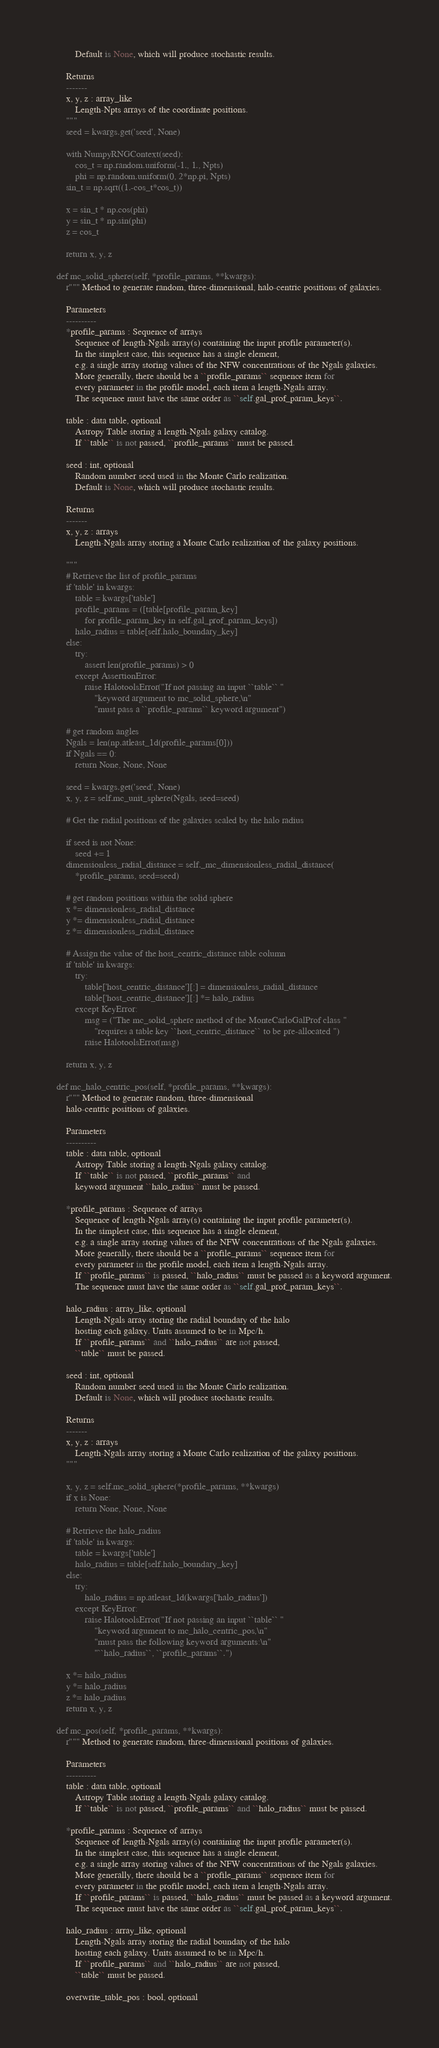Convert code to text. <code><loc_0><loc_0><loc_500><loc_500><_Python_>            Default is None, which will produce stochastic results.

        Returns
        -------
        x, y, z : array_like
            Length-Npts arrays of the coordinate positions.
        """
        seed = kwargs.get('seed', None)

        with NumpyRNGContext(seed):
            cos_t = np.random.uniform(-1., 1., Npts)
            phi = np.random.uniform(0, 2*np.pi, Npts)
        sin_t = np.sqrt((1.-cos_t*cos_t))

        x = sin_t * np.cos(phi)
        y = sin_t * np.sin(phi)
        z = cos_t

        return x, y, z

    def mc_solid_sphere(self, *profile_params, **kwargs):
        r""" Method to generate random, three-dimensional, halo-centric positions of galaxies.

        Parameters
        ----------
        *profile_params : Sequence of arrays
            Sequence of length-Ngals array(s) containing the input profile parameter(s).
            In the simplest case, this sequence has a single element,
            e.g. a single array storing values of the NFW concentrations of the Ngals galaxies.
            More generally, there should be a ``profile_params`` sequence item for
            every parameter in the profile model, each item a length-Ngals array.
            The sequence must have the same order as ``self.gal_prof_param_keys``.

        table : data table, optional
            Astropy Table storing a length-Ngals galaxy catalog.
            If ``table`` is not passed, ``profile_params`` must be passed.

        seed : int, optional
            Random number seed used in the Monte Carlo realization.
            Default is None, which will produce stochastic results.

        Returns
        -------
        x, y, z : arrays
            Length-Ngals array storing a Monte Carlo realization of the galaxy positions.

        """
        # Retrieve the list of profile_params
        if 'table' in kwargs:
            table = kwargs['table']
            profile_params = ([table[profile_param_key]
                for profile_param_key in self.gal_prof_param_keys])
            halo_radius = table[self.halo_boundary_key]
        else:
            try:
                assert len(profile_params) > 0
            except AssertionError:
                raise HalotoolsError("If not passing an input ``table`` "
                    "keyword argument to mc_solid_sphere,\n"
                    "must pass a ``profile_params`` keyword argument")

        # get random angles
        Ngals = len(np.atleast_1d(profile_params[0]))
        if Ngals == 0:
            return None, None, None

        seed = kwargs.get('seed', None)
        x, y, z = self.mc_unit_sphere(Ngals, seed=seed)

        # Get the radial positions of the galaxies scaled by the halo radius

        if seed is not None:
            seed += 1
        dimensionless_radial_distance = self._mc_dimensionless_radial_distance(
            *profile_params, seed=seed)

        # get random positions within the solid sphere
        x *= dimensionless_radial_distance
        y *= dimensionless_radial_distance
        z *= dimensionless_radial_distance

        # Assign the value of the host_centric_distance table column
        if 'table' in kwargs:
            try:
                table['host_centric_distance'][:] = dimensionless_radial_distance
                table['host_centric_distance'][:] *= halo_radius
            except KeyError:
                msg = ("The mc_solid_sphere method of the MonteCarloGalProf class "
                    "requires a table key ``host_centric_distance`` to be pre-allocated ")
                raise HalotoolsError(msg)

        return x, y, z

    def mc_halo_centric_pos(self, *profile_params, **kwargs):
        r""" Method to generate random, three-dimensional
        halo-centric positions of galaxies.

        Parameters
        ----------
        table : data table, optional
            Astropy Table storing a length-Ngals galaxy catalog.
            If ``table`` is not passed, ``profile_params`` and
            keyword argument ``halo_radius`` must be passed.

        *profile_params : Sequence of arrays
            Sequence of length-Ngals array(s) containing the input profile parameter(s).
            In the simplest case, this sequence has a single element,
            e.g. a single array storing values of the NFW concentrations of the Ngals galaxies.
            More generally, there should be a ``profile_params`` sequence item for
            every parameter in the profile model, each item a length-Ngals array.
            If ``profile_params`` is passed, ``halo_radius`` must be passed as a keyword argument.
            The sequence must have the same order as ``self.gal_prof_param_keys``.

        halo_radius : array_like, optional
            Length-Ngals array storing the radial boundary of the halo
            hosting each galaxy. Units assumed to be in Mpc/h.
            If ``profile_params`` and ``halo_radius`` are not passed,
            ``table`` must be passed.

        seed : int, optional
            Random number seed used in the Monte Carlo realization.
            Default is None, which will produce stochastic results.

        Returns
        -------
        x, y, z : arrays
            Length-Ngals array storing a Monte Carlo realization of the galaxy positions.
        """

        x, y, z = self.mc_solid_sphere(*profile_params, **kwargs)
        if x is None:
            return None, None, None

        # Retrieve the halo_radius
        if 'table' in kwargs:
            table = kwargs['table']
            halo_radius = table[self.halo_boundary_key]
        else:
            try:
                halo_radius = np.atleast_1d(kwargs['halo_radius'])
            except KeyError:
                raise HalotoolsError("If not passing an input ``table`` "
                    "keyword argument to mc_halo_centric_pos,\n"
                    "must pass the following keyword arguments:\n"
                    "``halo_radius``, ``profile_params``.")

        x *= halo_radius
        y *= halo_radius
        z *= halo_radius
        return x, y, z

    def mc_pos(self, *profile_params, **kwargs):
        r""" Method to generate random, three-dimensional positions of galaxies.

        Parameters
        ----------
        table : data table, optional
            Astropy Table storing a length-Ngals galaxy catalog.
            If ``table`` is not passed, ``profile_params`` and ``halo_radius`` must be passed.

        *profile_params : Sequence of arrays
            Sequence of length-Ngals array(s) containing the input profile parameter(s).
            In the simplest case, this sequence has a single element,
            e.g. a single array storing values of the NFW concentrations of the Ngals galaxies.
            More generally, there should be a ``profile_params`` sequence item for
            every parameter in the profile model, each item a length-Ngals array.
            If ``profile_params`` is passed, ``halo_radius`` must be passed as a keyword argument.
            The sequence must have the same order as ``self.gal_prof_param_keys``.

        halo_radius : array_like, optional
            Length-Ngals array storing the radial boundary of the halo
            hosting each galaxy. Units assumed to be in Mpc/h.
            If ``profile_params`` and ``halo_radius`` are not passed,
            ``table`` must be passed.

        overwrite_table_pos : bool, optional</code> 